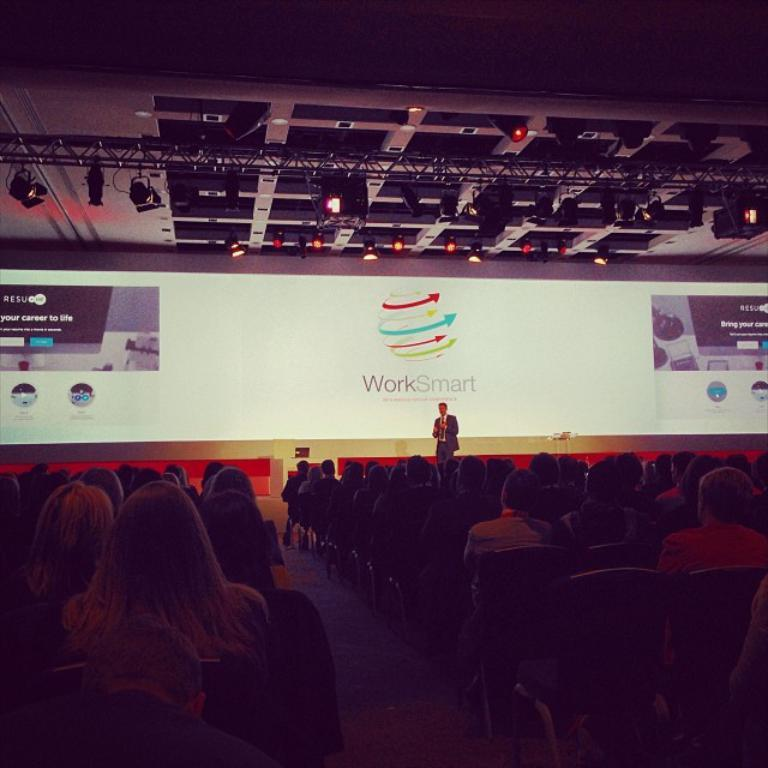What is happening on the stage in the image? There is a person standing on the stage in the image. How are the people arranged in relation to the stage? There is a group of people sitting in front of the stage, and they are facing the stage. What can be seen in the image that might be used for displaying visuals? There is a projector visible in the image. What type of structure is present in the image? There is a roof in the image. What type of ship can be seen sailing in the image? There is no ship present in the image; it features a person on stage, a group of people sitting in front of the stage, and a projector. How is the glue being used in the image? There is no glue present in the image. 